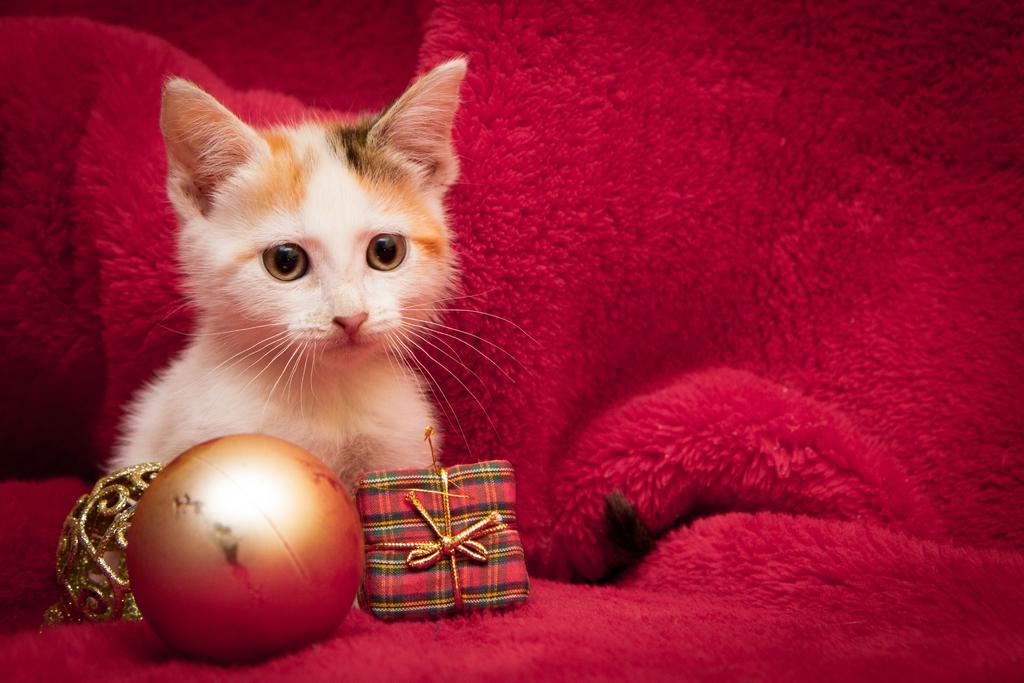In one or two sentences, can you explain what this image depicts? In the image there is a white cat with a ball and present in front of it on a red sofa. 